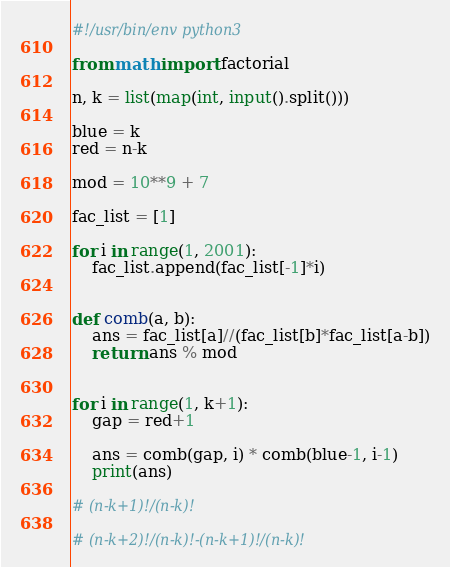<code> <loc_0><loc_0><loc_500><loc_500><_Python_>#!/usr/bin/env python3

from math import factorial

n, k = list(map(int, input().split()))

blue = k
red = n-k

mod = 10**9 + 7

fac_list = [1]

for i in range(1, 2001):
    fac_list.append(fac_list[-1]*i)


def comb(a, b):
    ans = fac_list[a]//(fac_list[b]*fac_list[a-b])
    return ans % mod


for i in range(1, k+1):
    gap = red+1

    ans = comb(gap, i) * comb(blue-1, i-1)
    print(ans)

# (n-k+1)!/(n-k)!

# (n-k+2)!/(n-k)!-(n-k+1)!/(n-k)!
</code> 